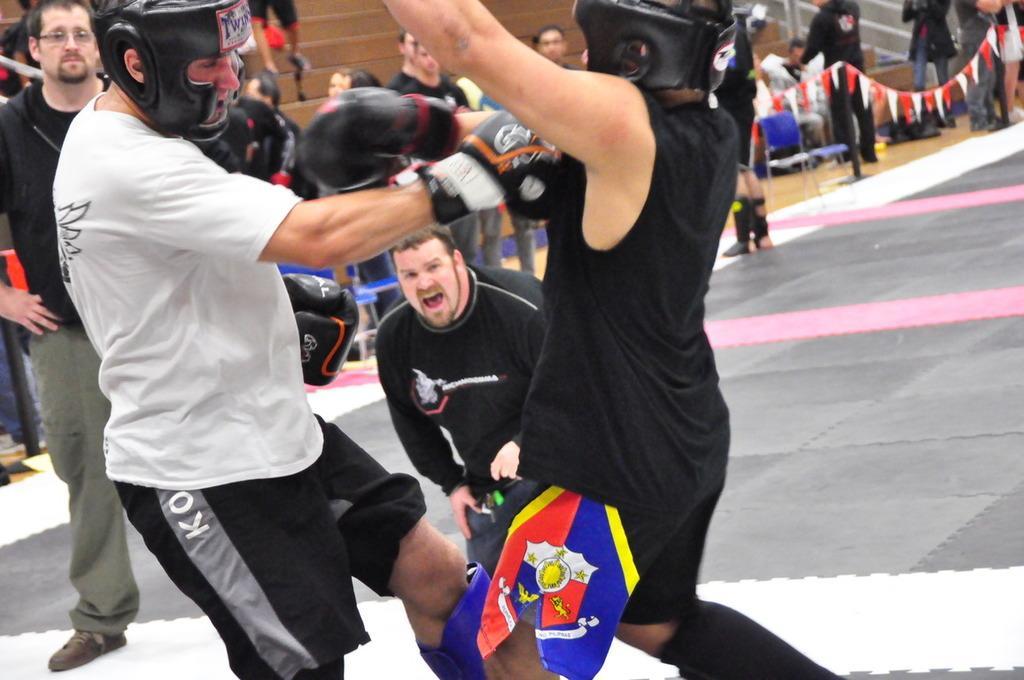How would you summarize this image in a sentence or two? In this image I can see two people with the helmets and boxing gloves. To the side of these people I can see many people standing and wearing the different color dresses. In the background I can see the stairs and the decorative papers which are in red and white color. 